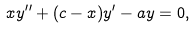<formula> <loc_0><loc_0><loc_500><loc_500>x y ^ { \prime \prime } + ( c - x ) y ^ { \prime } - a y = 0 ,</formula> 